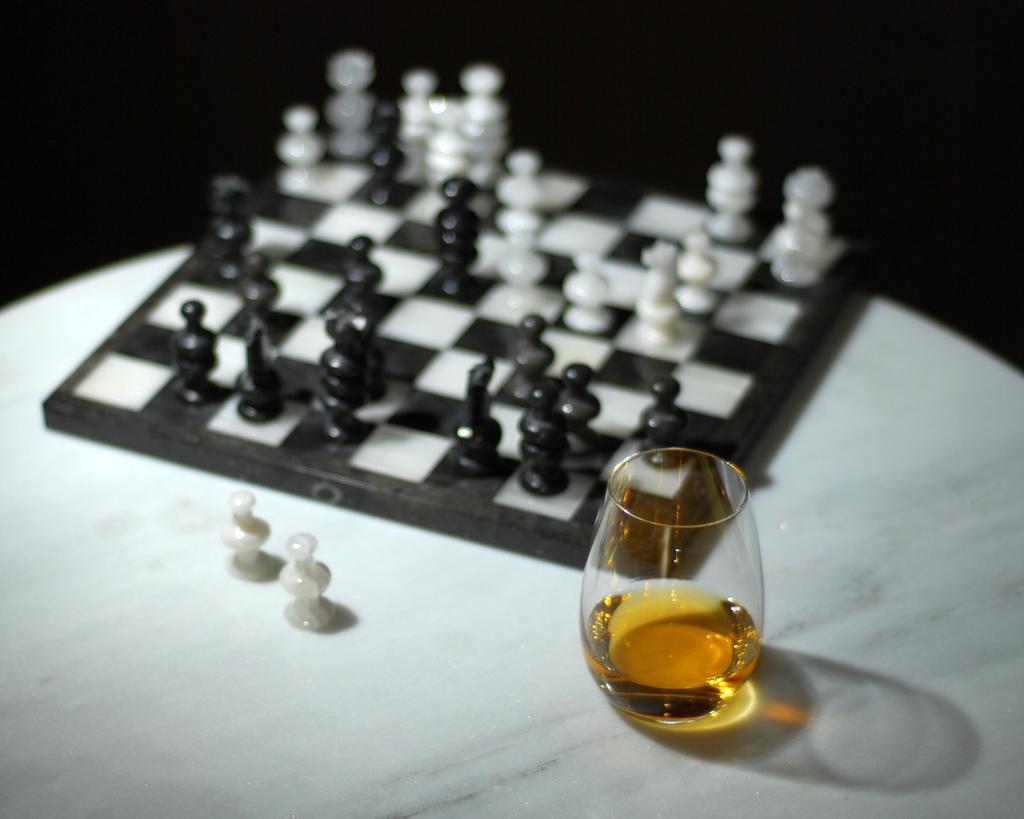In one or two sentences, can you explain what this image depicts? In the image there is a chess board with chess coins on it along with a wine glass on a table. 